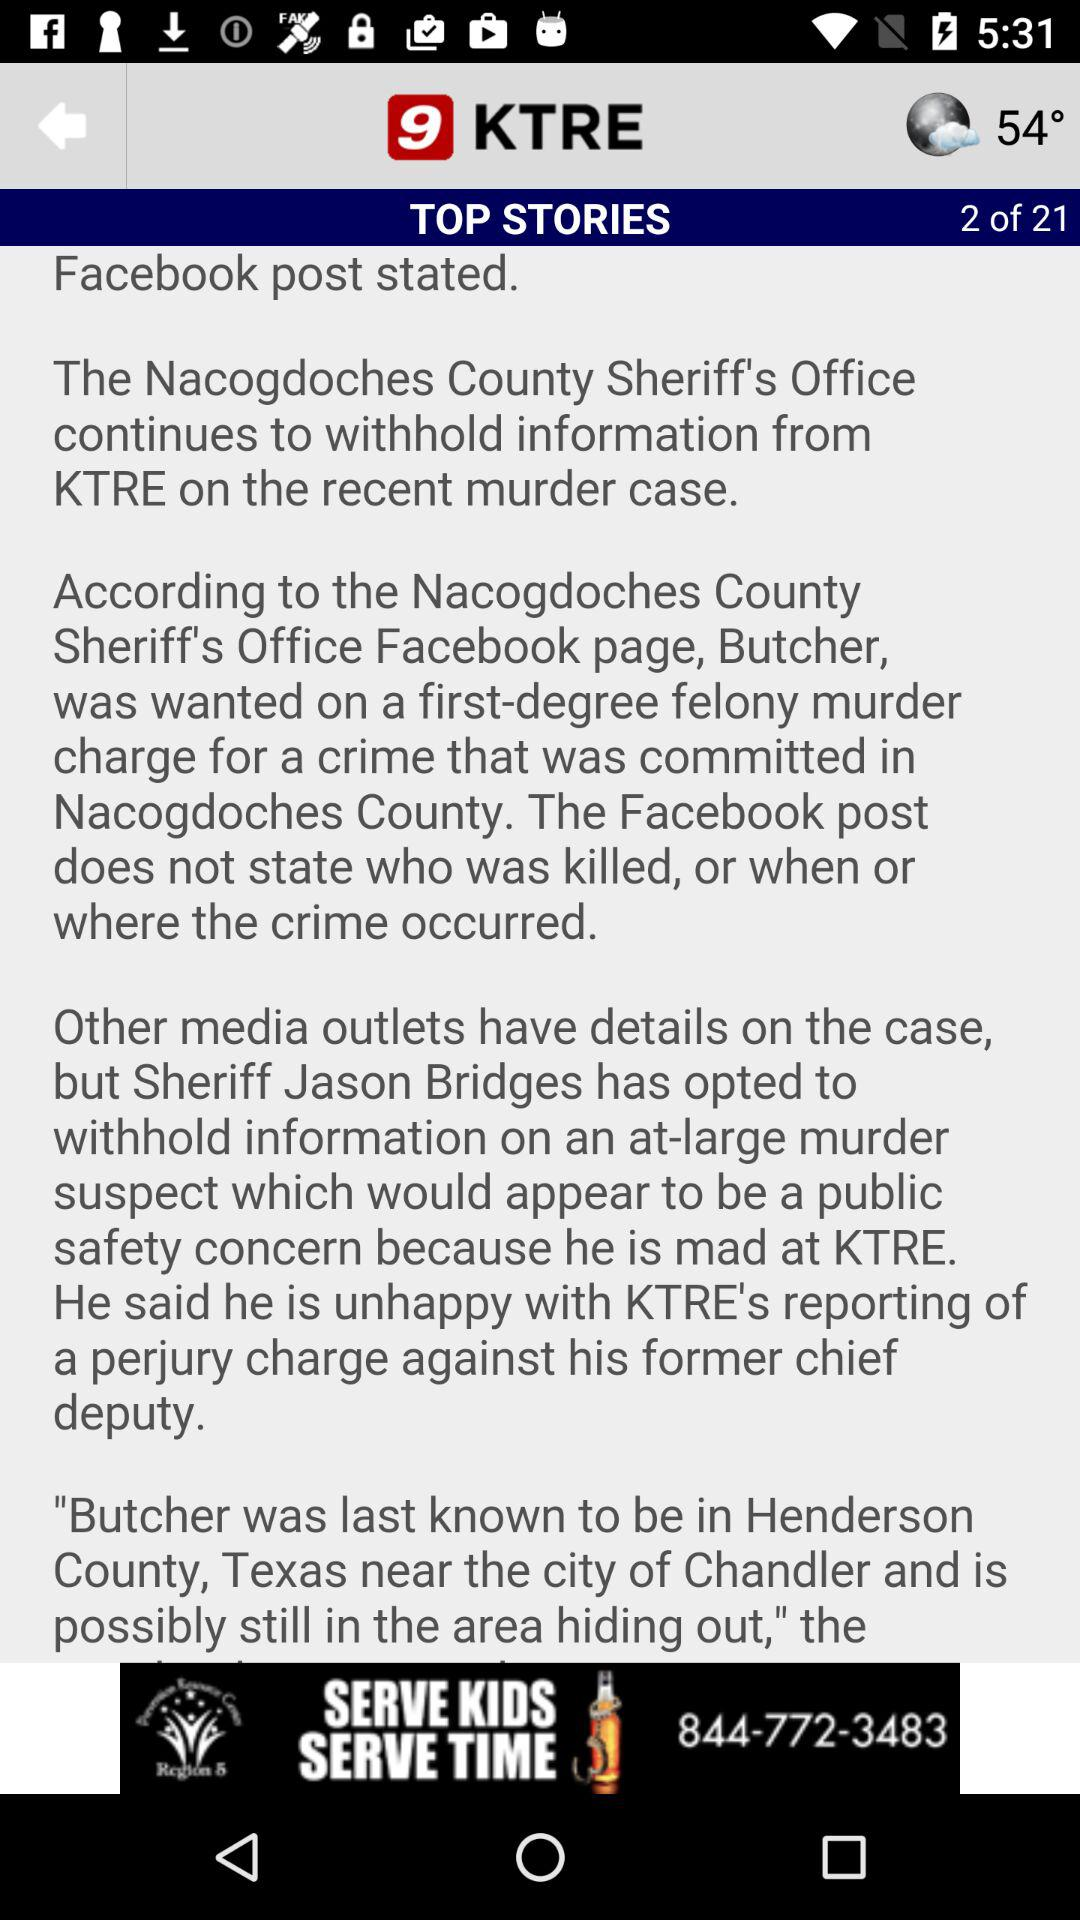How many pages in total are there in "Top Stories"? There are 21 pages. 